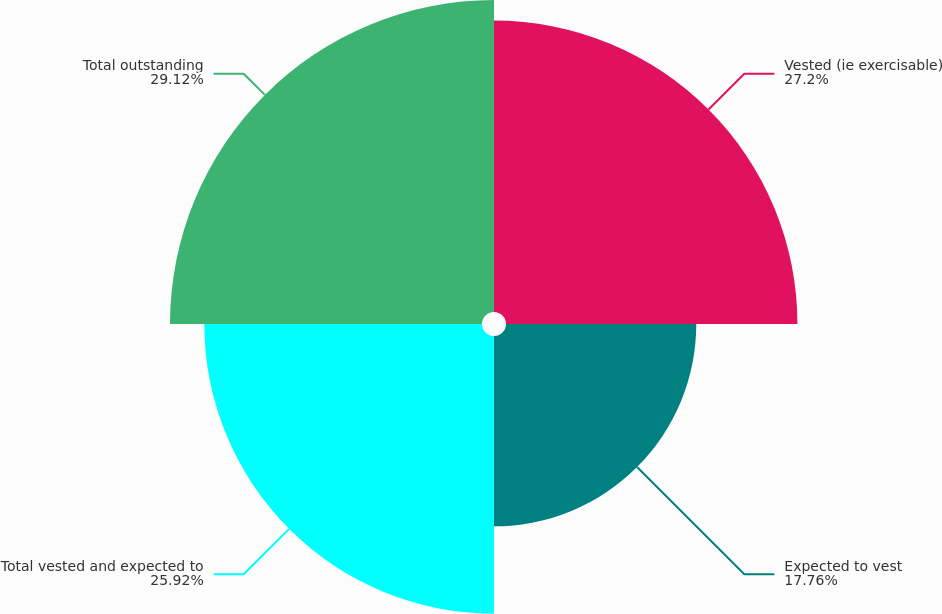<chart> <loc_0><loc_0><loc_500><loc_500><pie_chart><fcel>Vested (ie exercisable)<fcel>Expected to vest<fcel>Total vested and expected to<fcel>Total outstanding<nl><fcel>27.2%<fcel>17.76%<fcel>25.92%<fcel>29.12%<nl></chart> 